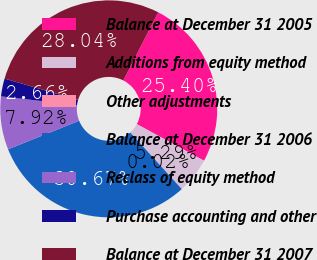<chart> <loc_0><loc_0><loc_500><loc_500><pie_chart><fcel>Balance at December 31 2005<fcel>Additions from equity method<fcel>Other adjustments<fcel>Balance at December 31 2006<fcel>Reclass of equity method<fcel>Purchase accounting and other<fcel>Balance at December 31 2007<nl><fcel>25.4%<fcel>5.29%<fcel>0.02%<fcel>30.67%<fcel>7.92%<fcel>2.66%<fcel>28.04%<nl></chart> 